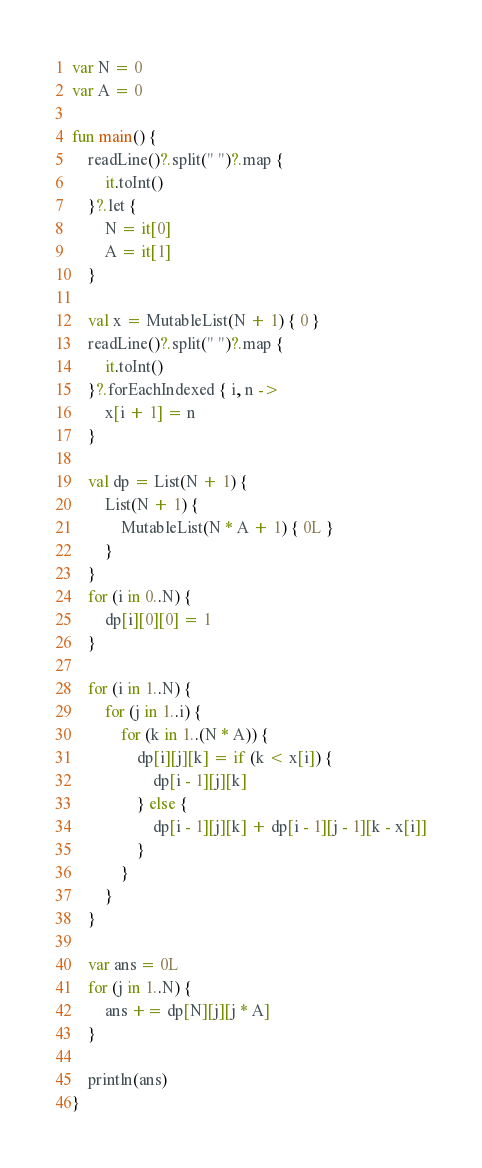<code> <loc_0><loc_0><loc_500><loc_500><_Kotlin_>var N = 0
var A = 0

fun main() {
    readLine()?.split(" ")?.map {
        it.toInt()
    }?.let {
        N = it[0]
        A = it[1]
    }

    val x = MutableList(N + 1) { 0 }
    readLine()?.split(" ")?.map {
        it.toInt()
    }?.forEachIndexed { i, n ->
        x[i + 1] = n
    }

    val dp = List(N + 1) {
        List(N + 1) {
            MutableList(N * A + 1) { 0L }
        }
    }
    for (i in 0..N) {
        dp[i][0][0] = 1
    }

    for (i in 1..N) {
        for (j in 1..i) {
            for (k in 1..(N * A)) {
                dp[i][j][k] = if (k < x[i]) {
                    dp[i - 1][j][k]
                } else {
                    dp[i - 1][j][k] + dp[i - 1][j - 1][k - x[i]]
                }
            }
        }
    }

    var ans = 0L
    for (j in 1..N) {
        ans += dp[N][j][j * A]
    }

    println(ans)
}

</code> 